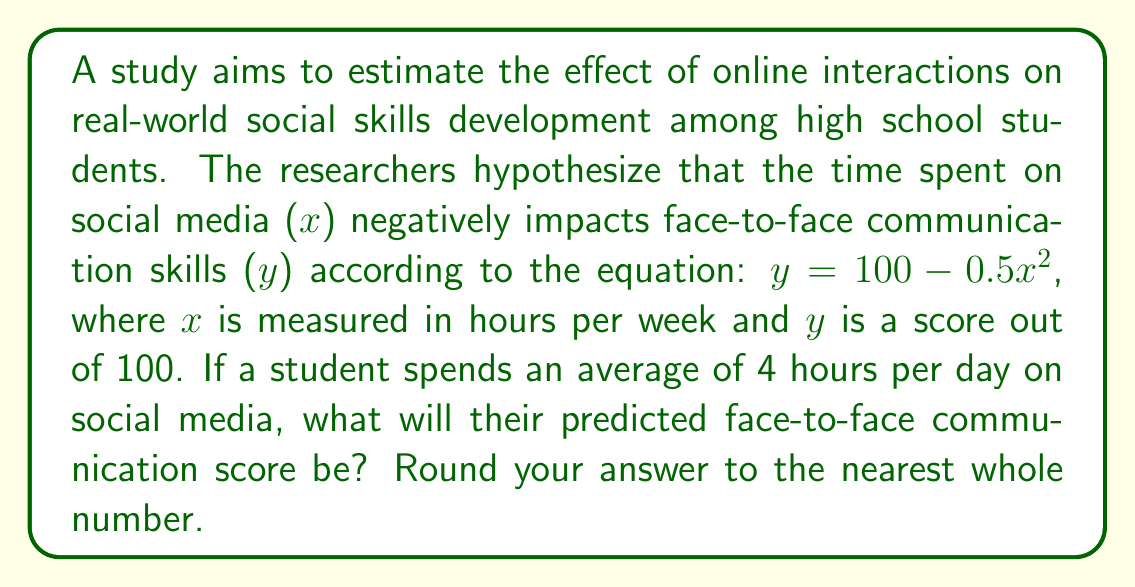Help me with this question. Let's approach this step-by-step:

1. Understand the given equation:
   $y = 100 - 0.5x^2$
   Where:
   y = face-to-face communication score (out of 100)
   x = time spent on social media (in hours per week)

2. Calculate the weekly social media usage:
   Daily usage = 4 hours
   Weekly usage = 4 hours × 7 days = 28 hours per week

3. Substitute x = 28 into the equation:
   $y = 100 - 0.5(28)^2$

4. Solve the equation:
   $y = 100 - 0.5(784)$
   $y = 100 - 392$
   $y = -292$

5. Interpret the result:
   The negative score doesn't make sense in the context of a 0-100 scale. This suggests that the model breaks down for extremely high social media usage. In reality, the score would likely bottom out at 0.

6. Adjust the result:
   Given the limitations of the model, we should cap the minimum score at 0.

7. Round to the nearest whole number:
   The final score is 0.
Answer: 0 